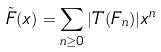<formula> <loc_0><loc_0><loc_500><loc_500>\tilde { F } ( x ) = \sum _ { n \geq 0 } | T ( F _ { n } ) | x ^ { n }</formula> 